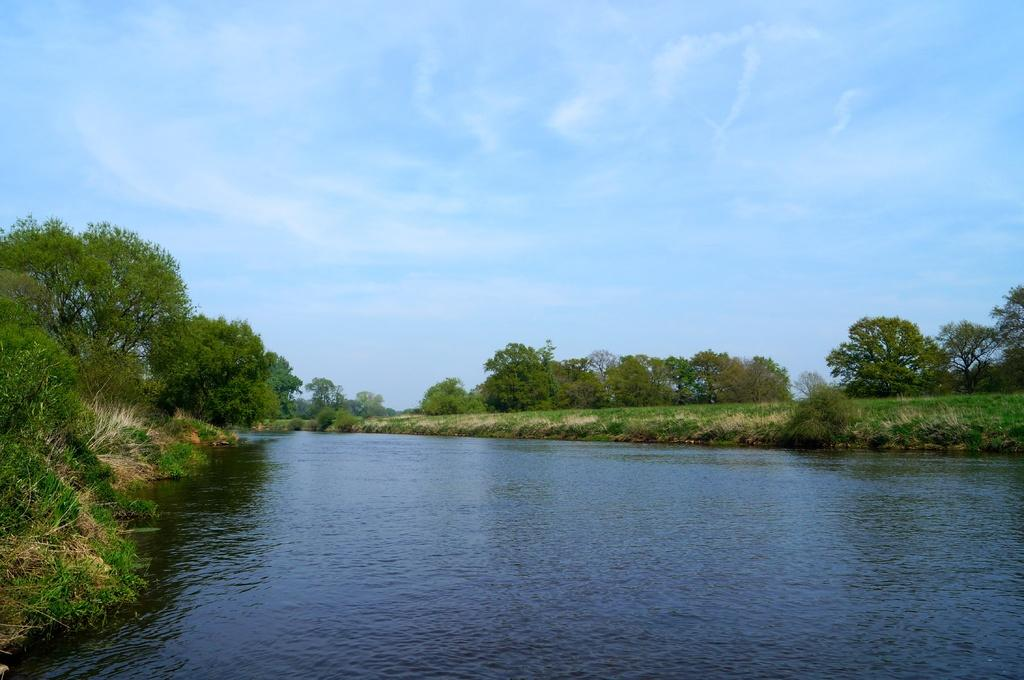What is present in the image that is not solid? There is water in the image. What can be seen on the left side of the image? There are trees on the left side of the image. What can be seen on the right side of the image? There are trees on the right side of the image. What color are the trees in the image? The trees are green in color. What colors are visible in the sky in the background of the image? The sky in the background is white and blue in color. What type of feast is being prepared by the women in the image? There are no women present in the image, and no feast is being prepared. 